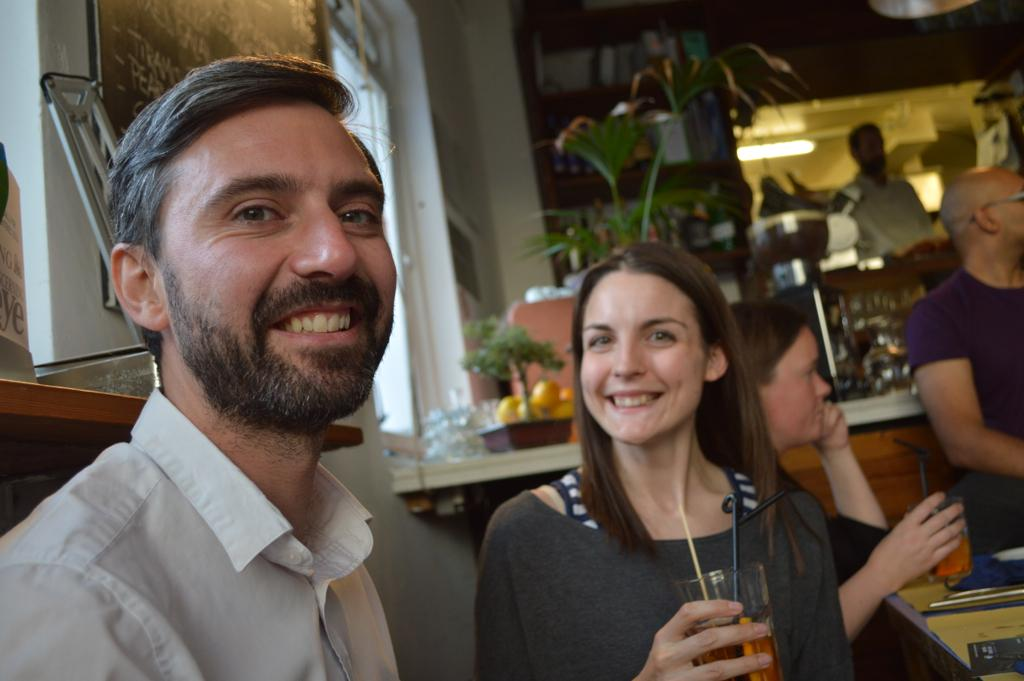Who or what is present in the image? There are people in the image. What are the people holding in their hands? The people are holding glasses in their hands. What type of vegetation can be seen in the image? There are plants visible in the image. What can be seen providing illumination in the image? There are lights in the image. How many pieces of furniture can be seen in the image? There is no furniture present in the image. What type of boy is visible in the image? There is no boy present in the image. Which toe of the person in the image is most visible? There are no visible toes in the image, as the people are holding glasses and not barefoot. 